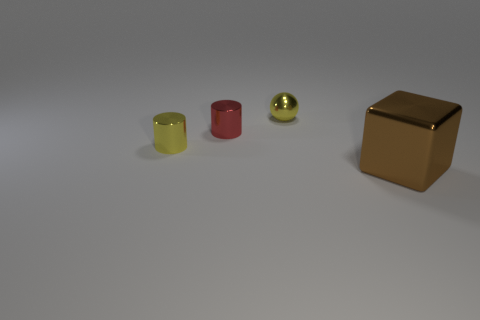What number of cubes are brown shiny things or small yellow objects?
Make the answer very short. 1. What number of brown things are behind the small yellow shiny object that is right of the small yellow thing that is left of the shiny sphere?
Offer a very short reply. 0. There is a yellow object that is the same shape as the red metal thing; what material is it?
Provide a succinct answer. Metal. Is there any other thing that is the same material as the brown thing?
Offer a terse response. Yes. The metallic object right of the small yellow shiny sphere is what color?
Your answer should be compact. Brown. Are the small red object and the thing right of the small sphere made of the same material?
Provide a succinct answer. Yes. What is the material of the cube?
Make the answer very short. Metal. There is a tiny red object that is the same material as the big object; what is its shape?
Give a very brief answer. Cylinder. How many other things are there of the same shape as the brown thing?
Offer a terse response. 0. There is a large brown shiny cube; how many cylinders are on the left side of it?
Your response must be concise. 2. 